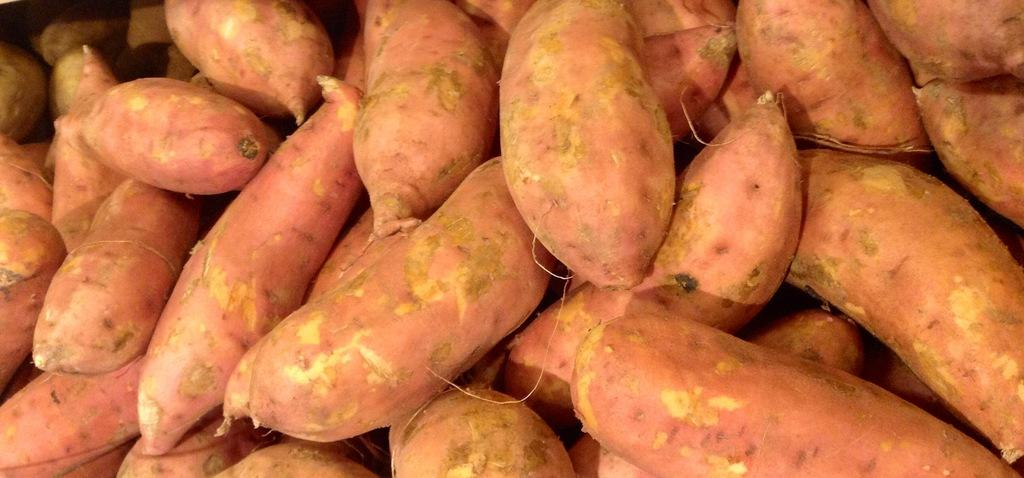What type of food is visible in the image? There are sweet potatoes in the image. How many sweet potatoes are present in the image? The sweet potatoes are in a bulk quantity. Can you determine the time of day when the image was taken? The image was likely taken during the day. What type of reaction can be seen from the horses in the image? There are no horses present in the image, so it is not possible to determine their reaction. 